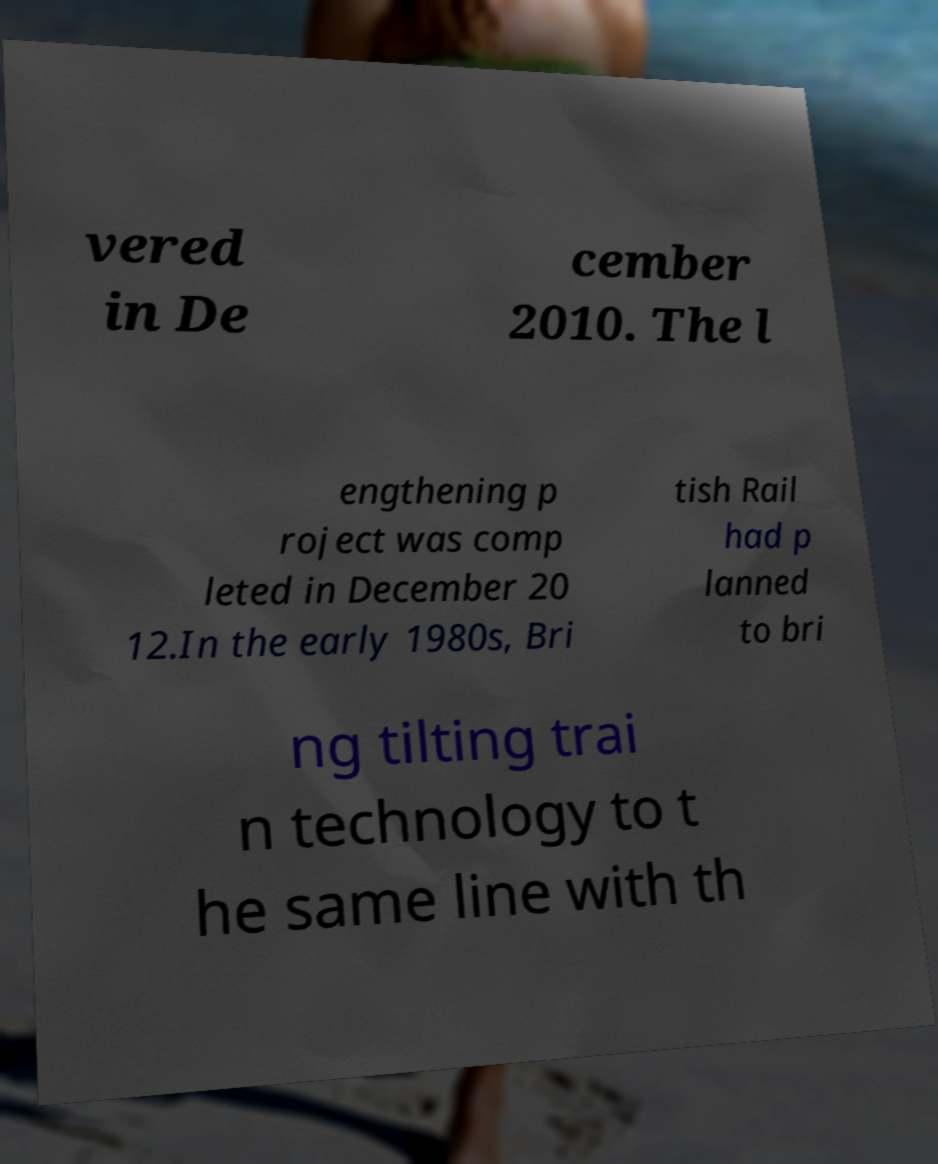Could you extract and type out the text from this image? vered in De cember 2010. The l engthening p roject was comp leted in December 20 12.In the early 1980s, Bri tish Rail had p lanned to bri ng tilting trai n technology to t he same line with th 